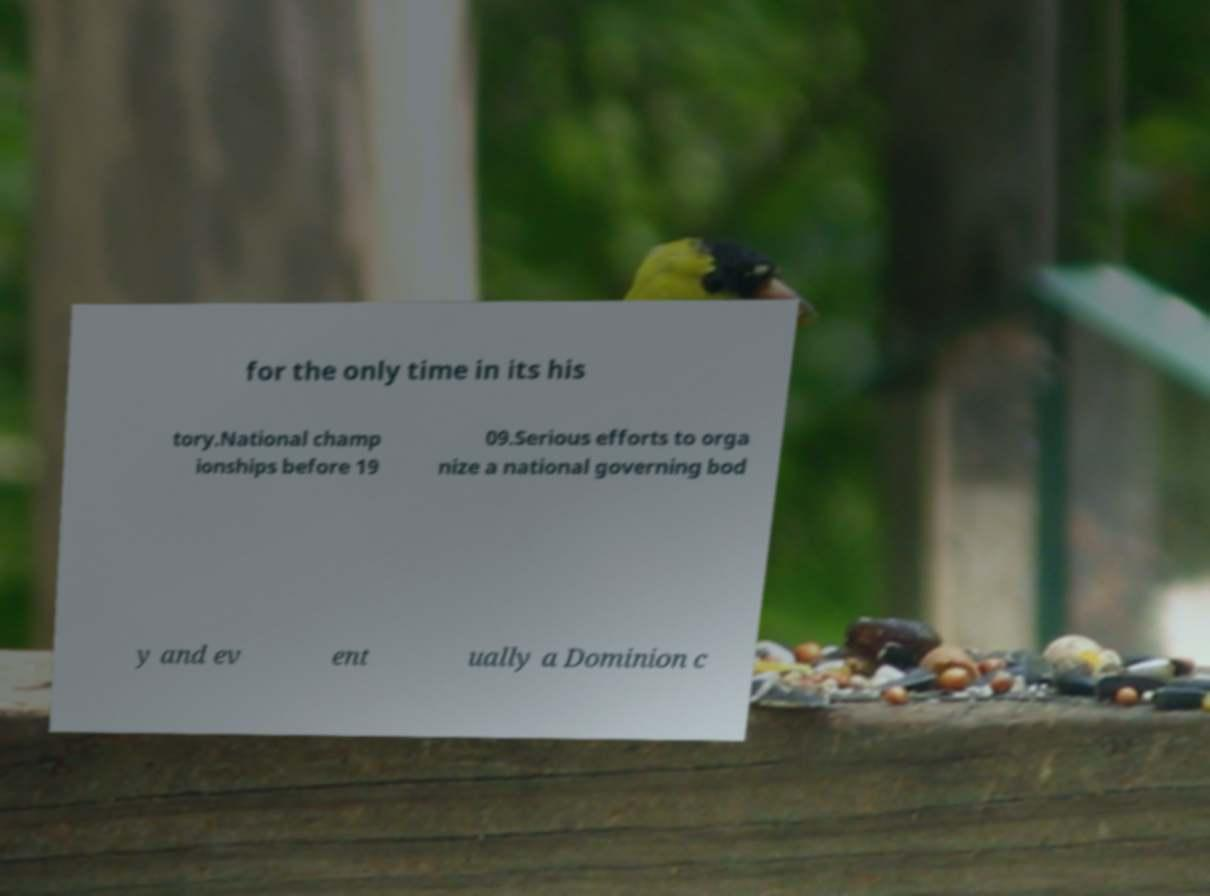There's text embedded in this image that I need extracted. Can you transcribe it verbatim? for the only time in its his tory.National champ ionships before 19 09.Serious efforts to orga nize a national governing bod y and ev ent ually a Dominion c 